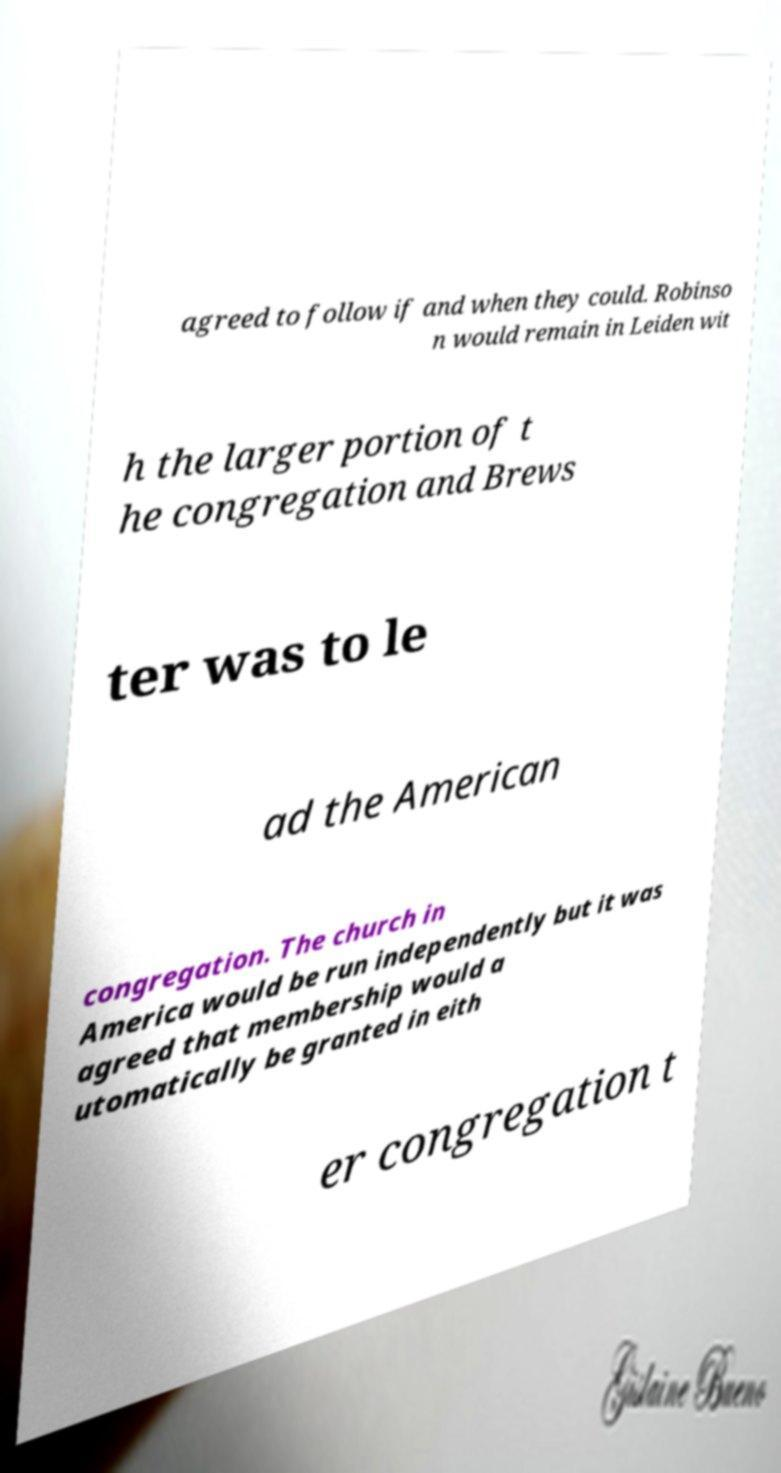Can you read and provide the text displayed in the image?This photo seems to have some interesting text. Can you extract and type it out for me? agreed to follow if and when they could. Robinso n would remain in Leiden wit h the larger portion of t he congregation and Brews ter was to le ad the American congregation. The church in America would be run independently but it was agreed that membership would a utomatically be granted in eith er congregation t 